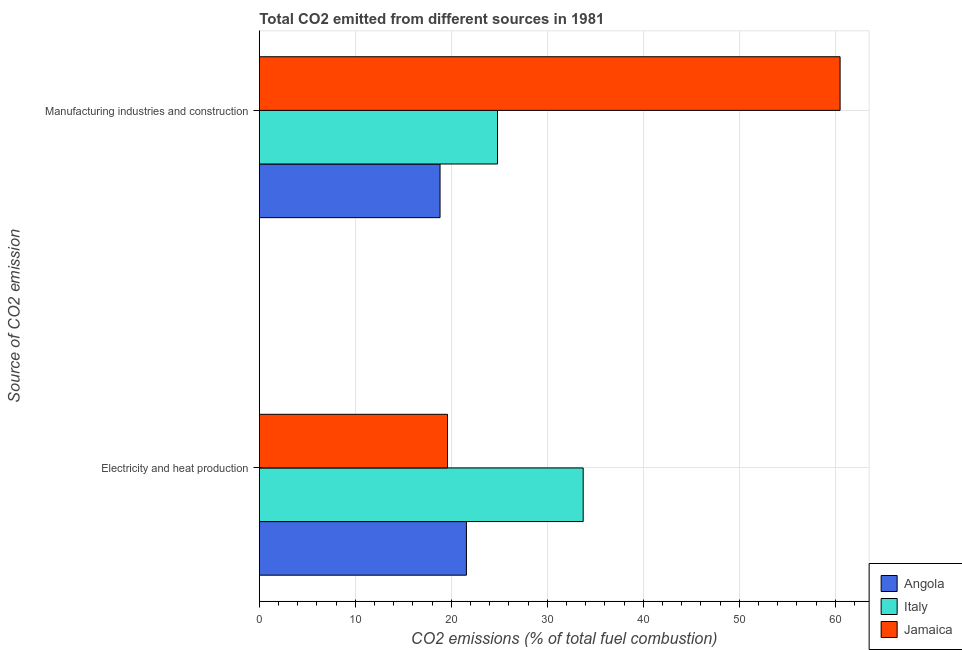How many groups of bars are there?
Provide a short and direct response. 2. Are the number of bars per tick equal to the number of legend labels?
Give a very brief answer. Yes. How many bars are there on the 2nd tick from the bottom?
Give a very brief answer. 3. What is the label of the 1st group of bars from the top?
Offer a terse response. Manufacturing industries and construction. What is the co2 emissions due to manufacturing industries in Italy?
Offer a terse response. 24.81. Across all countries, what is the maximum co2 emissions due to manufacturing industries?
Your response must be concise. 60.49. Across all countries, what is the minimum co2 emissions due to manufacturing industries?
Give a very brief answer. 18.82. In which country was the co2 emissions due to electricity and heat production maximum?
Keep it short and to the point. Italy. In which country was the co2 emissions due to electricity and heat production minimum?
Offer a terse response. Jamaica. What is the total co2 emissions due to manufacturing industries in the graph?
Provide a succinct answer. 104.13. What is the difference between the co2 emissions due to manufacturing industries in Angola and that in Italy?
Offer a terse response. -5.98. What is the difference between the co2 emissions due to manufacturing industries in Jamaica and the co2 emissions due to electricity and heat production in Angola?
Offer a very short reply. 38.93. What is the average co2 emissions due to manufacturing industries per country?
Your response must be concise. 34.71. What is the difference between the co2 emissions due to manufacturing industries and co2 emissions due to electricity and heat production in Jamaica?
Provide a succinct answer. 40.9. In how many countries, is the co2 emissions due to manufacturing industries greater than 50 %?
Ensure brevity in your answer.  1. What is the ratio of the co2 emissions due to manufacturing industries in Italy to that in Jamaica?
Your answer should be very brief. 0.41. Is the co2 emissions due to electricity and heat production in Italy less than that in Angola?
Your response must be concise. No. In how many countries, is the co2 emissions due to manufacturing industries greater than the average co2 emissions due to manufacturing industries taken over all countries?
Your answer should be compact. 1. What does the 2nd bar from the top in Manufacturing industries and construction represents?
Your response must be concise. Italy. How many bars are there?
Provide a succinct answer. 6. How many countries are there in the graph?
Ensure brevity in your answer.  3. What is the difference between two consecutive major ticks on the X-axis?
Your response must be concise. 10. Are the values on the major ticks of X-axis written in scientific E-notation?
Offer a very short reply. No. Does the graph contain any zero values?
Your answer should be compact. No. Does the graph contain grids?
Offer a very short reply. Yes. What is the title of the graph?
Provide a succinct answer. Total CO2 emitted from different sources in 1981. Does "Faeroe Islands" appear as one of the legend labels in the graph?
Your response must be concise. No. What is the label or title of the X-axis?
Keep it short and to the point. CO2 emissions (% of total fuel combustion). What is the label or title of the Y-axis?
Offer a very short reply. Source of CO2 emission. What is the CO2 emissions (% of total fuel combustion) in Angola in Electricity and heat production?
Offer a terse response. 21.57. What is the CO2 emissions (% of total fuel combustion) of Italy in Electricity and heat production?
Offer a very short reply. 33.73. What is the CO2 emissions (% of total fuel combustion) of Jamaica in Electricity and heat production?
Offer a terse response. 19.6. What is the CO2 emissions (% of total fuel combustion) of Angola in Manufacturing industries and construction?
Provide a short and direct response. 18.82. What is the CO2 emissions (% of total fuel combustion) of Italy in Manufacturing industries and construction?
Your answer should be compact. 24.81. What is the CO2 emissions (% of total fuel combustion) of Jamaica in Manufacturing industries and construction?
Keep it short and to the point. 60.49. Across all Source of CO2 emission, what is the maximum CO2 emissions (% of total fuel combustion) of Angola?
Provide a short and direct response. 21.57. Across all Source of CO2 emission, what is the maximum CO2 emissions (% of total fuel combustion) of Italy?
Your response must be concise. 33.73. Across all Source of CO2 emission, what is the maximum CO2 emissions (% of total fuel combustion) in Jamaica?
Ensure brevity in your answer.  60.49. Across all Source of CO2 emission, what is the minimum CO2 emissions (% of total fuel combustion) in Angola?
Provide a short and direct response. 18.82. Across all Source of CO2 emission, what is the minimum CO2 emissions (% of total fuel combustion) of Italy?
Your answer should be very brief. 24.81. Across all Source of CO2 emission, what is the minimum CO2 emissions (% of total fuel combustion) in Jamaica?
Ensure brevity in your answer.  19.6. What is the total CO2 emissions (% of total fuel combustion) of Angola in the graph?
Provide a succinct answer. 40.39. What is the total CO2 emissions (% of total fuel combustion) in Italy in the graph?
Keep it short and to the point. 58.54. What is the total CO2 emissions (% of total fuel combustion) in Jamaica in the graph?
Give a very brief answer. 80.09. What is the difference between the CO2 emissions (% of total fuel combustion) in Angola in Electricity and heat production and that in Manufacturing industries and construction?
Your response must be concise. 2.75. What is the difference between the CO2 emissions (% of total fuel combustion) in Italy in Electricity and heat production and that in Manufacturing industries and construction?
Provide a succinct answer. 8.93. What is the difference between the CO2 emissions (% of total fuel combustion) in Jamaica in Electricity and heat production and that in Manufacturing industries and construction?
Provide a succinct answer. -40.9. What is the difference between the CO2 emissions (% of total fuel combustion) in Angola in Electricity and heat production and the CO2 emissions (% of total fuel combustion) in Italy in Manufacturing industries and construction?
Provide a succinct answer. -3.24. What is the difference between the CO2 emissions (% of total fuel combustion) in Angola in Electricity and heat production and the CO2 emissions (% of total fuel combustion) in Jamaica in Manufacturing industries and construction?
Offer a terse response. -38.93. What is the difference between the CO2 emissions (% of total fuel combustion) of Italy in Electricity and heat production and the CO2 emissions (% of total fuel combustion) of Jamaica in Manufacturing industries and construction?
Ensure brevity in your answer.  -26.76. What is the average CO2 emissions (% of total fuel combustion) in Angola per Source of CO2 emission?
Keep it short and to the point. 20.2. What is the average CO2 emissions (% of total fuel combustion) in Italy per Source of CO2 emission?
Provide a succinct answer. 29.27. What is the average CO2 emissions (% of total fuel combustion) in Jamaica per Source of CO2 emission?
Provide a succinct answer. 40.05. What is the difference between the CO2 emissions (% of total fuel combustion) in Angola and CO2 emissions (% of total fuel combustion) in Italy in Electricity and heat production?
Offer a terse response. -12.16. What is the difference between the CO2 emissions (% of total fuel combustion) of Angola and CO2 emissions (% of total fuel combustion) of Jamaica in Electricity and heat production?
Your response must be concise. 1.97. What is the difference between the CO2 emissions (% of total fuel combustion) in Italy and CO2 emissions (% of total fuel combustion) in Jamaica in Electricity and heat production?
Offer a very short reply. 14.13. What is the difference between the CO2 emissions (% of total fuel combustion) of Angola and CO2 emissions (% of total fuel combustion) of Italy in Manufacturing industries and construction?
Offer a very short reply. -5.98. What is the difference between the CO2 emissions (% of total fuel combustion) of Angola and CO2 emissions (% of total fuel combustion) of Jamaica in Manufacturing industries and construction?
Give a very brief answer. -41.67. What is the difference between the CO2 emissions (% of total fuel combustion) of Italy and CO2 emissions (% of total fuel combustion) of Jamaica in Manufacturing industries and construction?
Your response must be concise. -35.69. What is the ratio of the CO2 emissions (% of total fuel combustion) of Angola in Electricity and heat production to that in Manufacturing industries and construction?
Give a very brief answer. 1.15. What is the ratio of the CO2 emissions (% of total fuel combustion) of Italy in Electricity and heat production to that in Manufacturing industries and construction?
Give a very brief answer. 1.36. What is the ratio of the CO2 emissions (% of total fuel combustion) in Jamaica in Electricity and heat production to that in Manufacturing industries and construction?
Your response must be concise. 0.32. What is the difference between the highest and the second highest CO2 emissions (% of total fuel combustion) in Angola?
Ensure brevity in your answer.  2.75. What is the difference between the highest and the second highest CO2 emissions (% of total fuel combustion) in Italy?
Offer a terse response. 8.93. What is the difference between the highest and the second highest CO2 emissions (% of total fuel combustion) of Jamaica?
Your answer should be compact. 40.9. What is the difference between the highest and the lowest CO2 emissions (% of total fuel combustion) of Angola?
Offer a very short reply. 2.75. What is the difference between the highest and the lowest CO2 emissions (% of total fuel combustion) in Italy?
Offer a terse response. 8.93. What is the difference between the highest and the lowest CO2 emissions (% of total fuel combustion) of Jamaica?
Your answer should be compact. 40.9. 